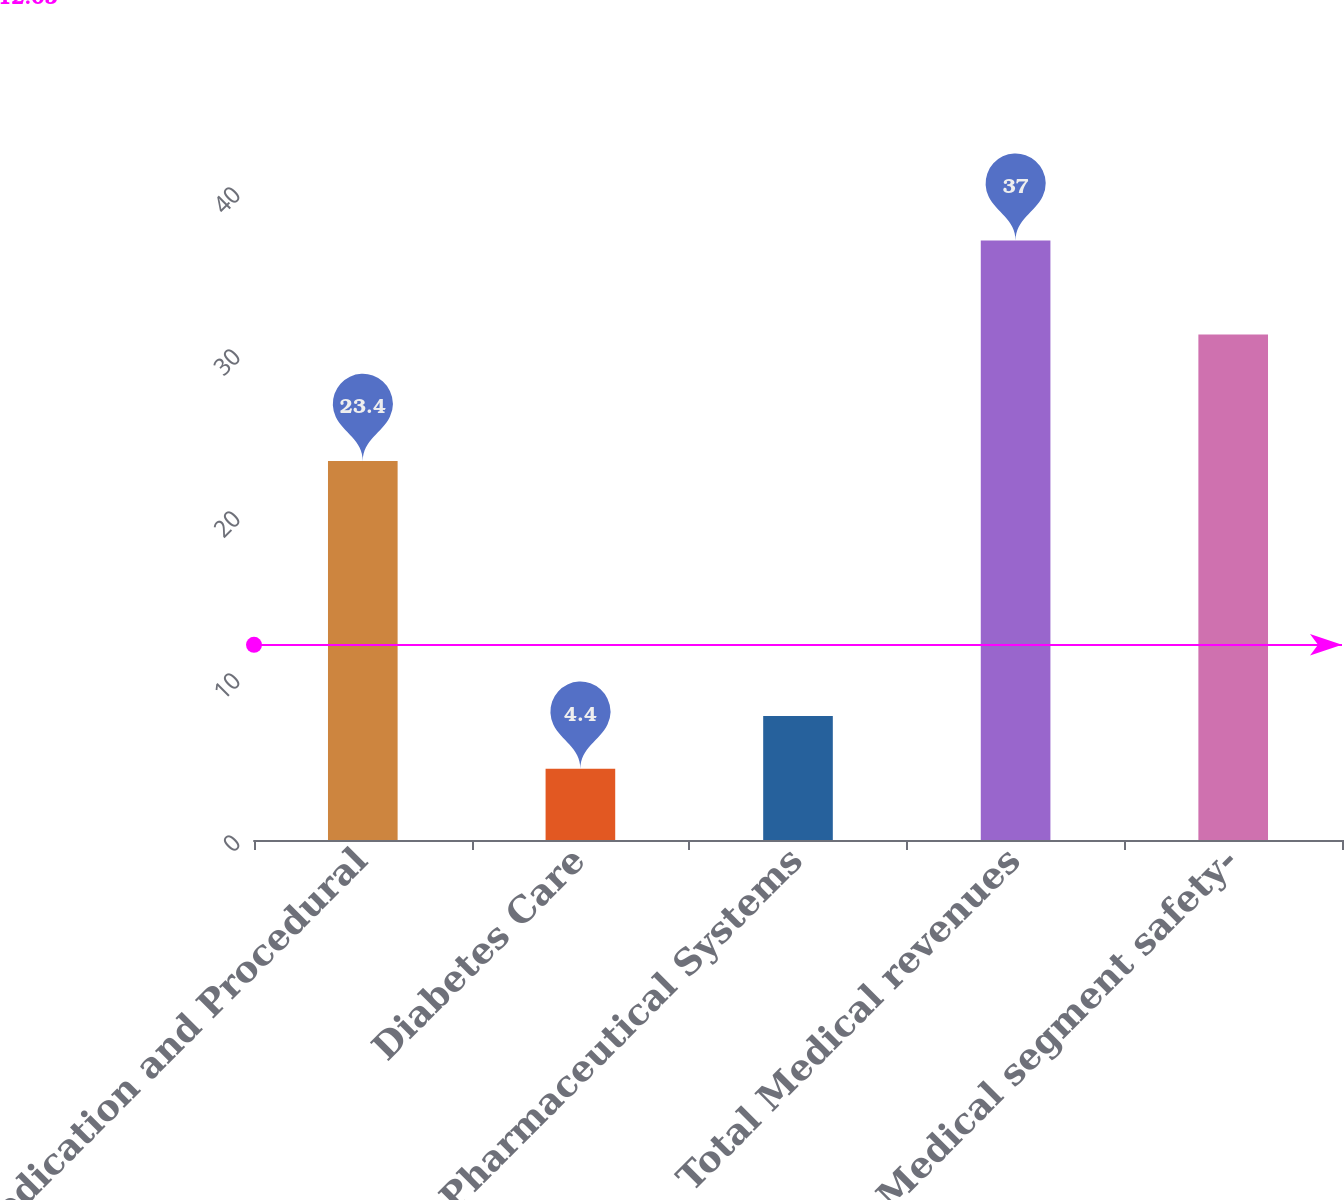<chart> <loc_0><loc_0><loc_500><loc_500><bar_chart><fcel>Medication and Procedural<fcel>Diabetes Care<fcel>Pharmaceutical Systems<fcel>Total Medical revenues<fcel>Medical segment safety-<nl><fcel>23.4<fcel>4.4<fcel>7.66<fcel>37<fcel>31.2<nl></chart> 